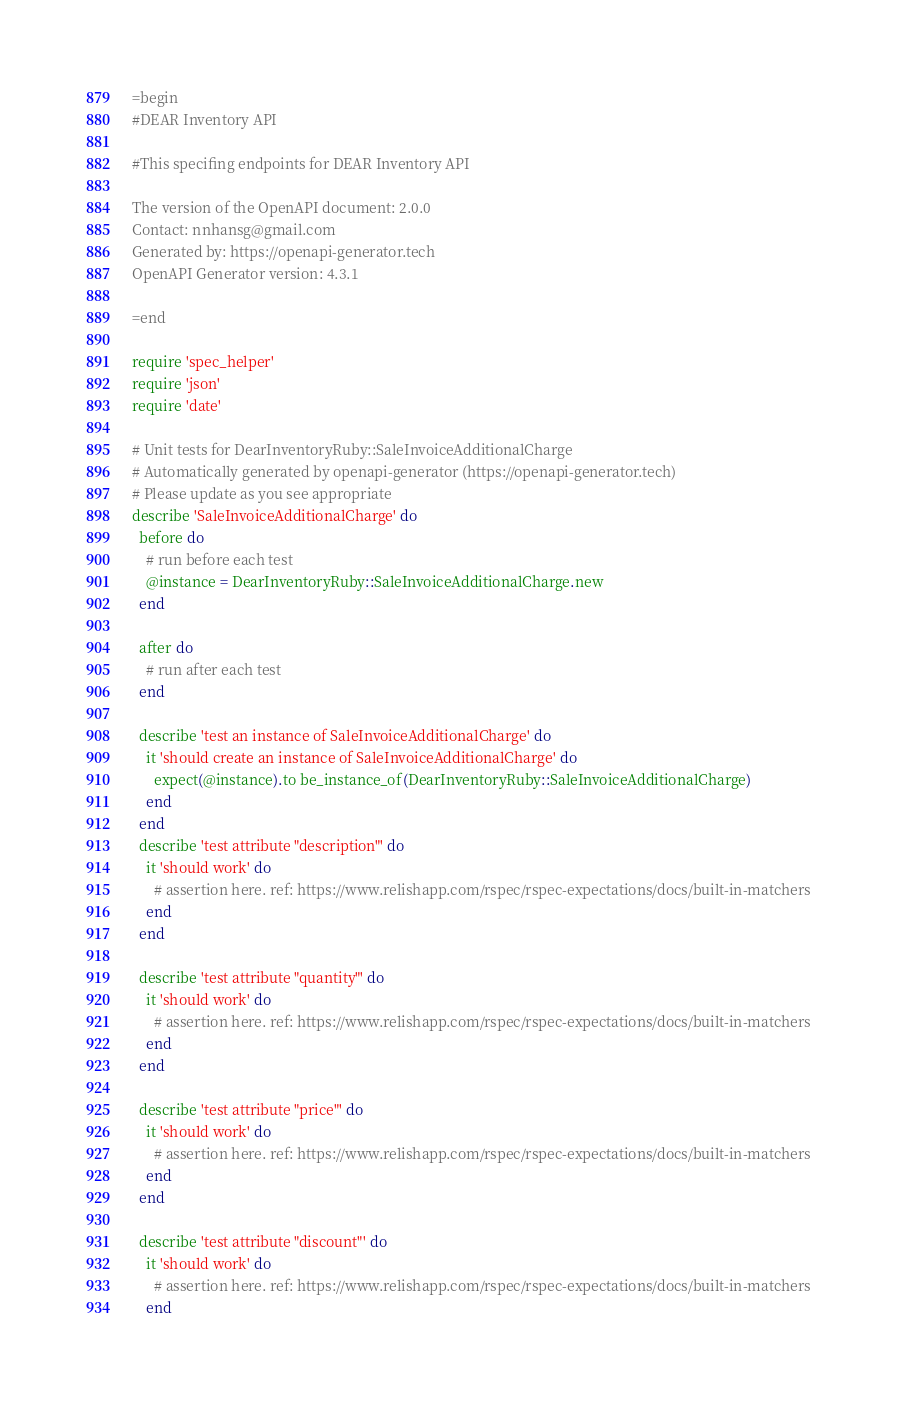<code> <loc_0><loc_0><loc_500><loc_500><_Ruby_>=begin
#DEAR Inventory API

#This specifing endpoints for DEAR Inventory API

The version of the OpenAPI document: 2.0.0
Contact: nnhansg@gmail.com
Generated by: https://openapi-generator.tech
OpenAPI Generator version: 4.3.1

=end

require 'spec_helper'
require 'json'
require 'date'

# Unit tests for DearInventoryRuby::SaleInvoiceAdditionalCharge
# Automatically generated by openapi-generator (https://openapi-generator.tech)
# Please update as you see appropriate
describe 'SaleInvoiceAdditionalCharge' do
  before do
    # run before each test
    @instance = DearInventoryRuby::SaleInvoiceAdditionalCharge.new
  end

  after do
    # run after each test
  end

  describe 'test an instance of SaleInvoiceAdditionalCharge' do
    it 'should create an instance of SaleInvoiceAdditionalCharge' do
      expect(@instance).to be_instance_of(DearInventoryRuby::SaleInvoiceAdditionalCharge)
    end
  end
  describe 'test attribute "description"' do
    it 'should work' do
      # assertion here. ref: https://www.relishapp.com/rspec/rspec-expectations/docs/built-in-matchers
    end
  end

  describe 'test attribute "quantity"' do
    it 'should work' do
      # assertion here. ref: https://www.relishapp.com/rspec/rspec-expectations/docs/built-in-matchers
    end
  end

  describe 'test attribute "price"' do
    it 'should work' do
      # assertion here. ref: https://www.relishapp.com/rspec/rspec-expectations/docs/built-in-matchers
    end
  end

  describe 'test attribute "discount"' do
    it 'should work' do
      # assertion here. ref: https://www.relishapp.com/rspec/rspec-expectations/docs/built-in-matchers
    end</code> 